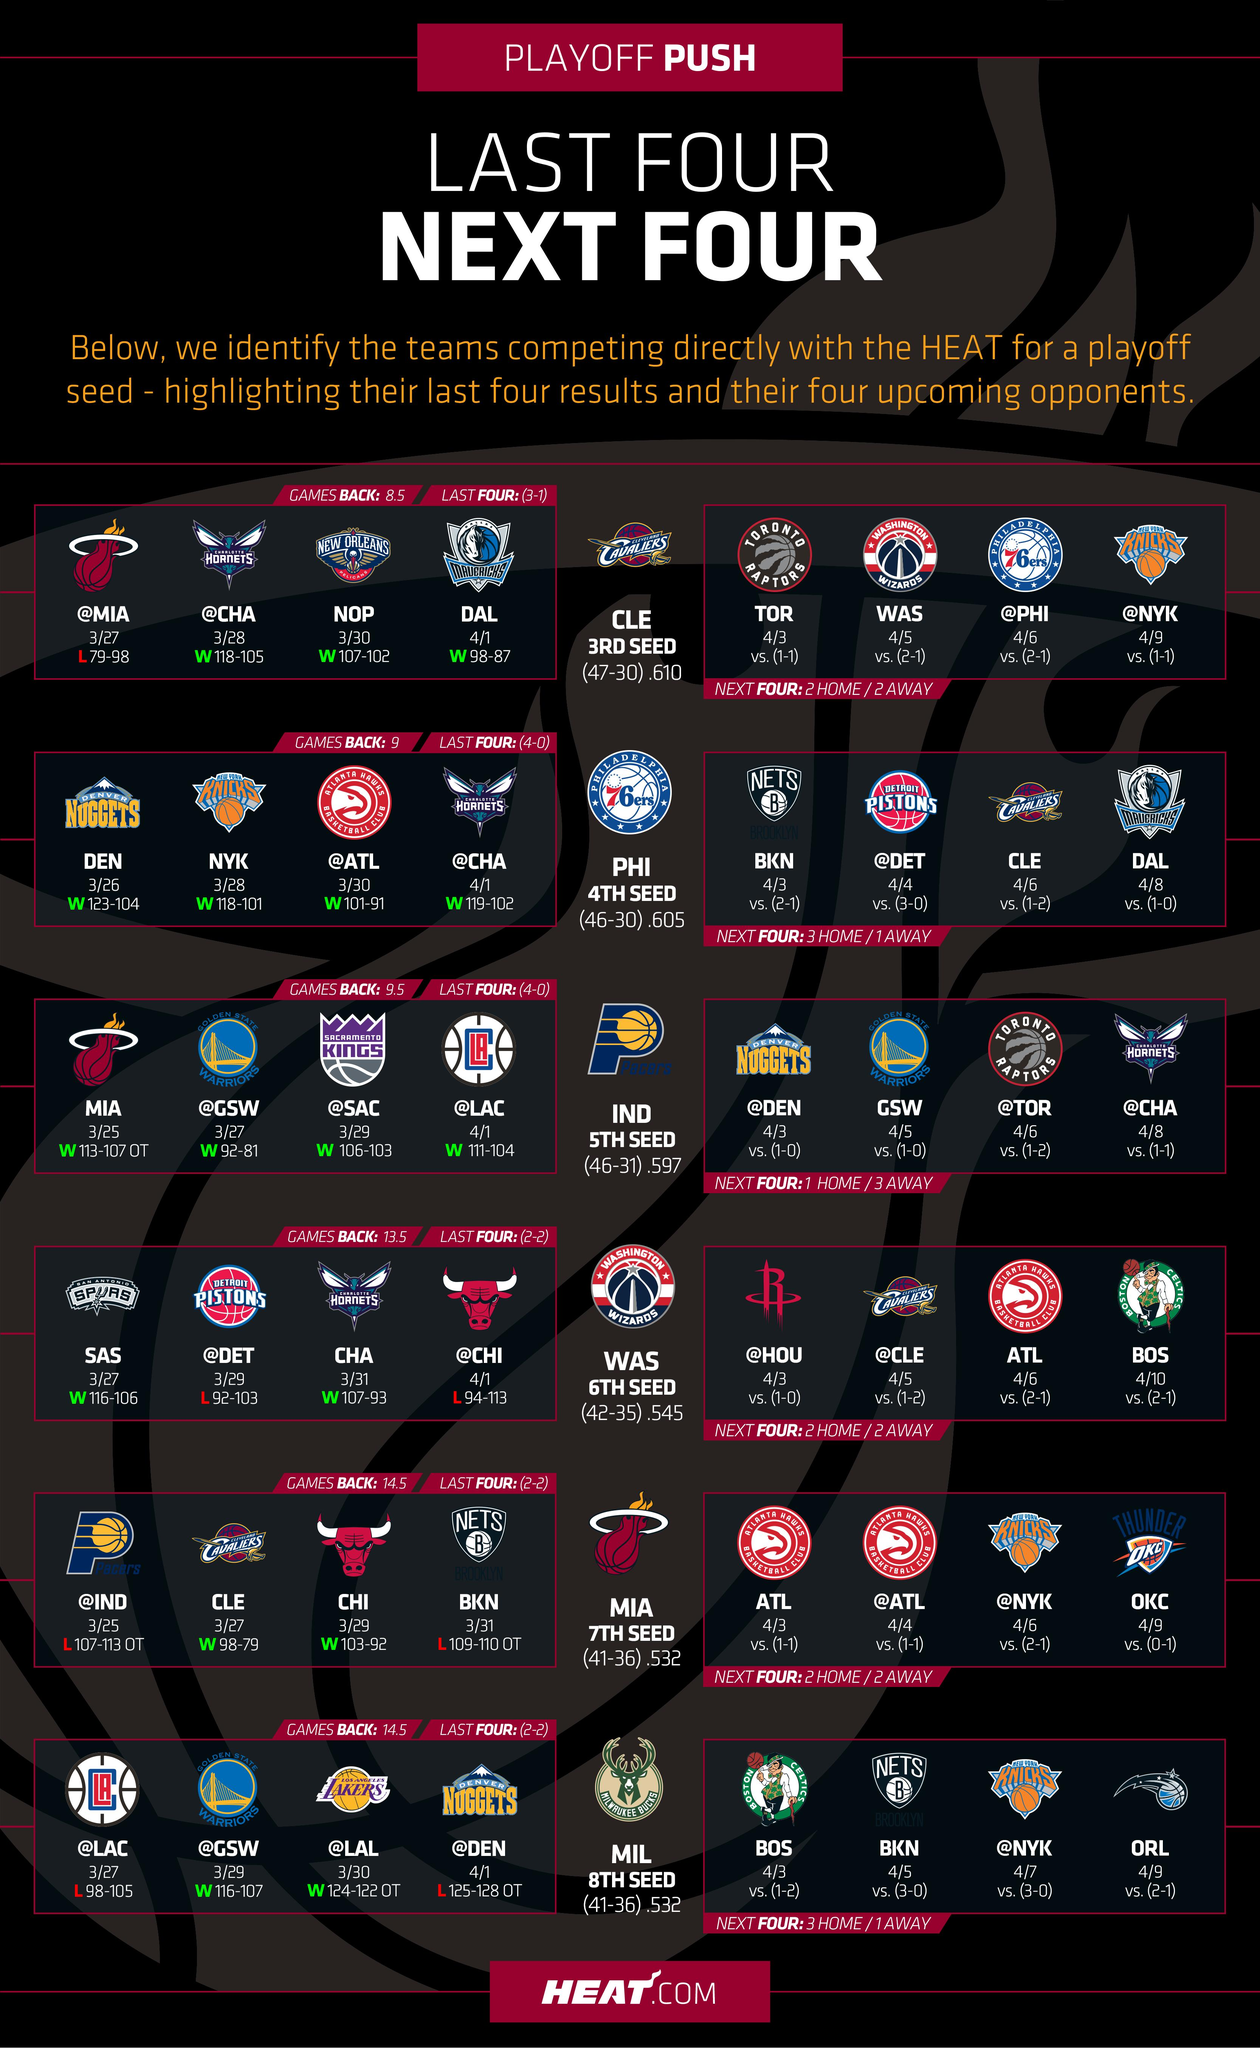Give some essential details in this illustration. The infographic contains six rows. 